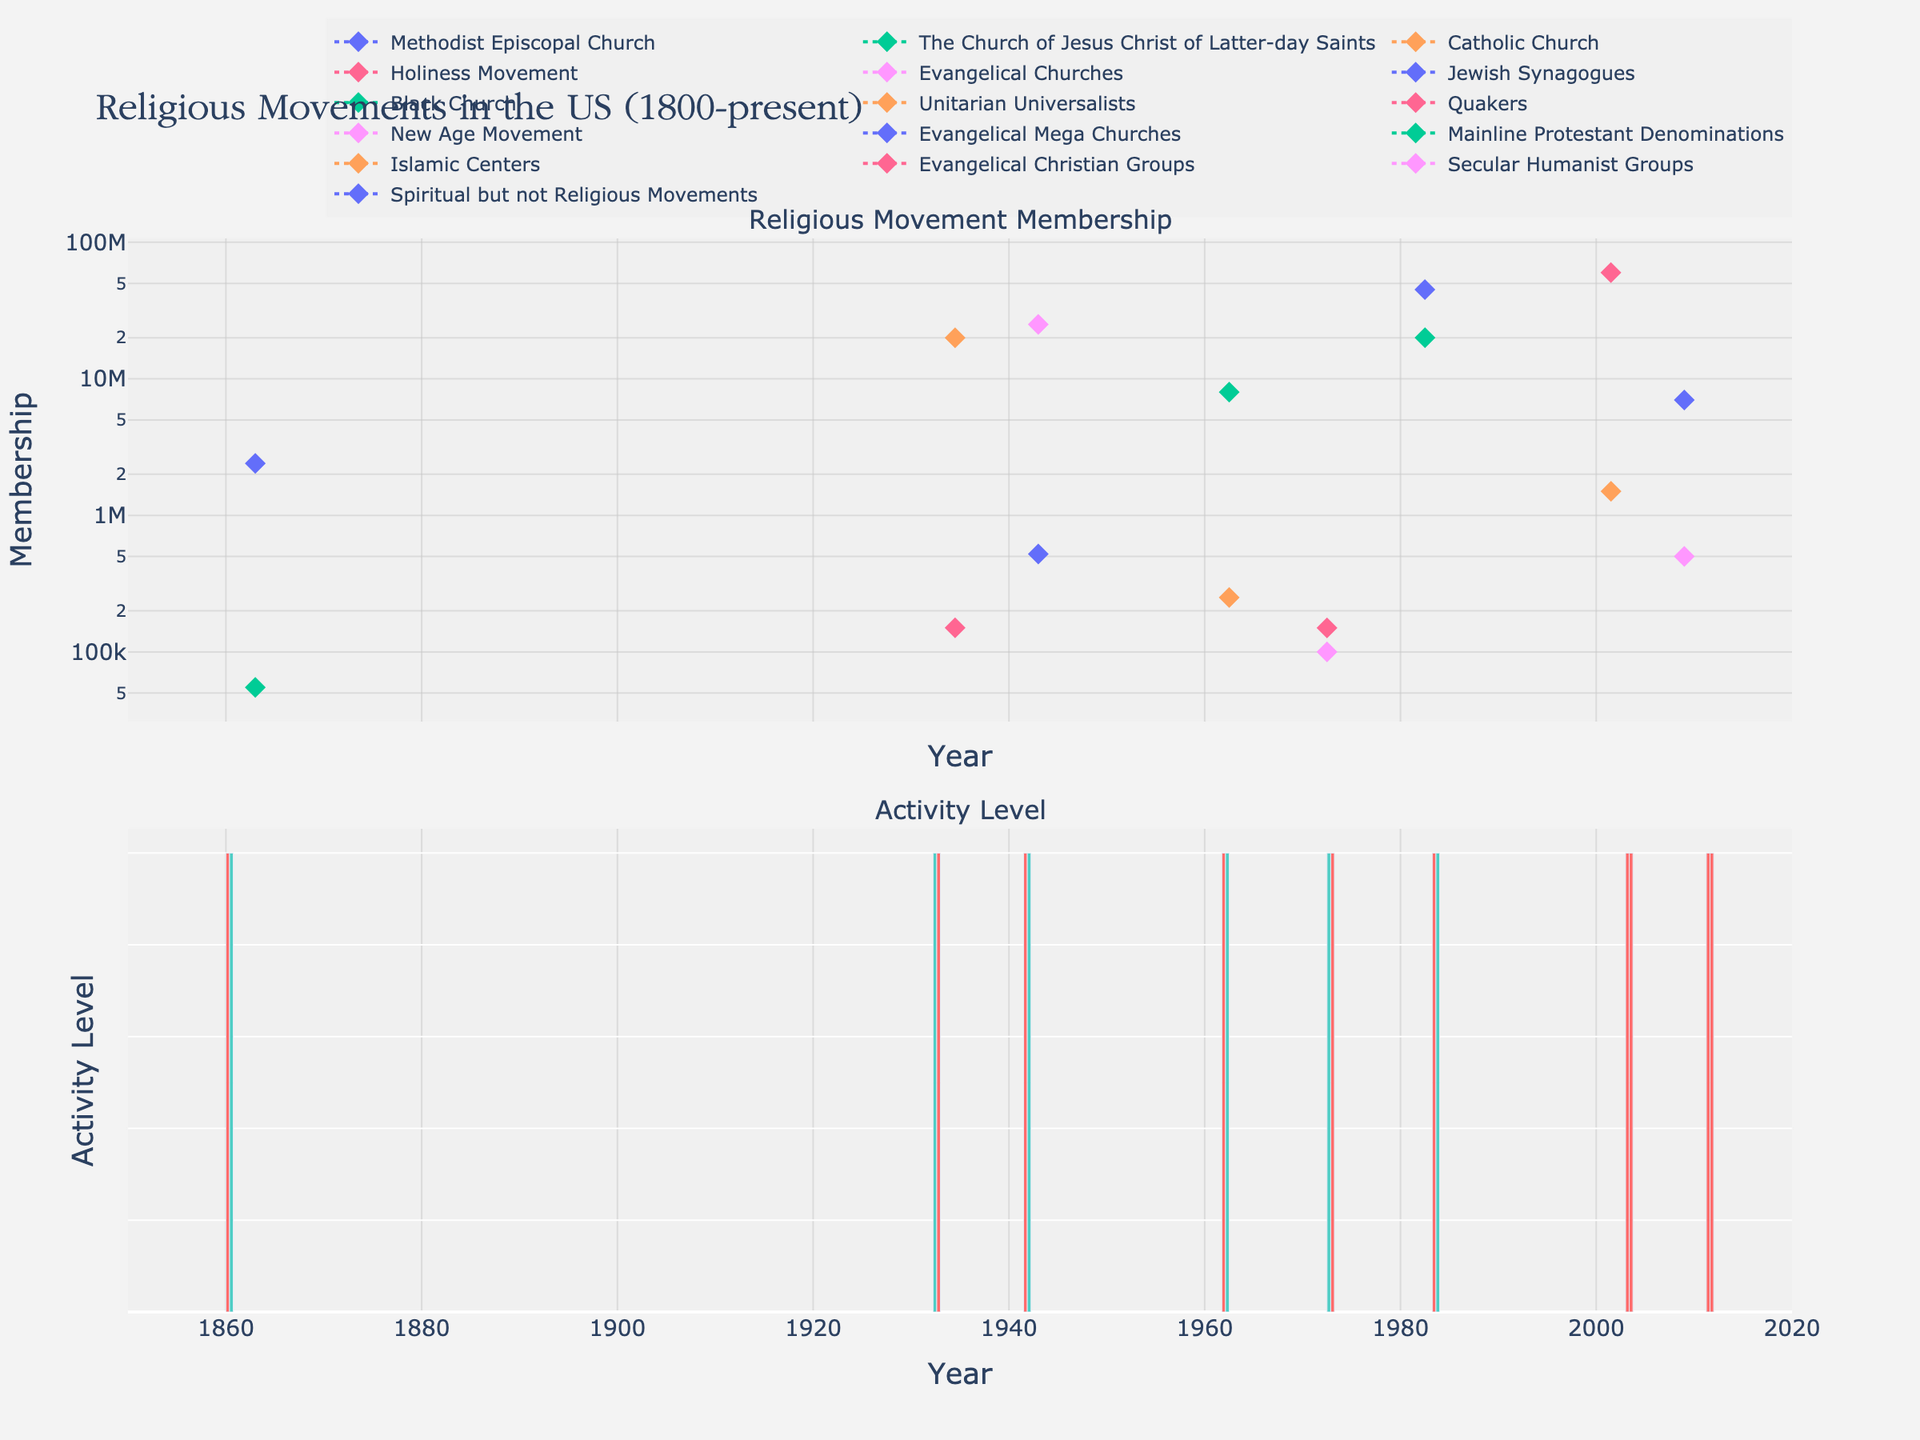What is the main title of the figure? The title is usually located at the top of the figure, providing an overview of what the plot represents. In this case, it should be "Religious Movements in the US (1800-present)".
Answer: Religious Movements in the US (1800-present) What are the two subplots displayed in the figure? The subplot titles usually indicate the type of data being shown. Here, the subplots are titled "Religious Movement Membership" and "Activity Level".
Answer: Religious Movement Membership, Activity Level Which religious movement had the highest membership during Reaganomics? Look at the membership values for the Reaganomics period (1980-1985). The highest value is for Evangelical Mega Churches with 45,000,000 members.
Answer: Evangelical Mega Churches What was the activity level of the Jewish Synagogues during World War II? Check the color of the bars in the Activity Level subplot for World War II (1941-1945). The Jewish Synagogues have a moderate activity, which is indicated by the color green.
Answer: Moderate How did the membership of the Methodist Episcopal Church during the American Civil War compare to that of The Church of Jesus Christ of Latter-day Saints during the same period? Compare the membership values for both during 1861-1865. The Methodist Episcopal Church had 2,400,000 members while The Church of Jesus Christ of Latter-day Saints had 55,000 members. The former is much higher.
Answer: Methodist Episcopal Church had more members During which historical event did the Spiritual but not Religious Movements see high activity? Locate the time periods where the Spiritual but not Religious Movements appears and note the historical events. This group had high activity during the Great Recession (2008-2010).
Answer: Great Recession Compare the activity levels of Quakers and the New Age Movement during the Vietnam War. Check the bar colors for the Vietnam War period (1970-1975). Both the Quakers and New Age Movement are shown, and both have a moderate activity level.
Answer: Both have moderate activity What is the overall trend in membership for Evangelical Christian Groups from World War II to September 11 Attacks? Track the membership values for Evangelical Christian Groups from 1941-1945 (World War II) to 2001-2002 (September 11 Attacks). The value increases from 25,000,000 to 60,000,000, indicating an upward trend.
Answer: Upward trend What are the colors used to represent 'High' and 'Moderate' activity levels? Look at the color scale for activity levels in the Activity Level subplot. 'High' is indicated by red, and 'Moderate' is indicated by green.
Answer: Red (High), Green (Moderate) 